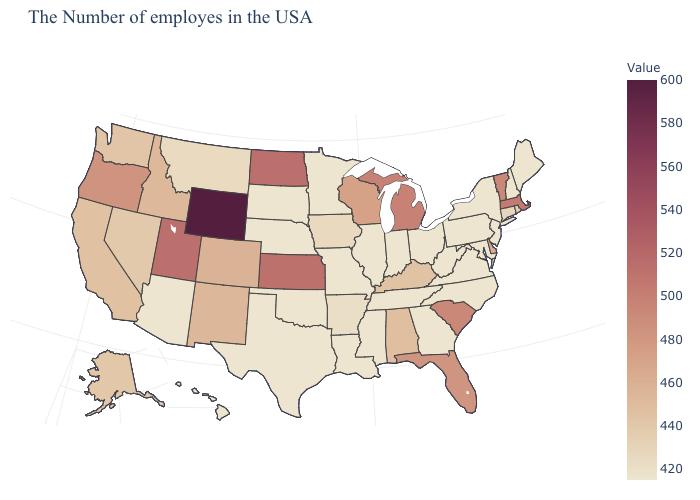Which states have the highest value in the USA?
Short answer required. Wyoming. Does Massachusetts have the lowest value in the USA?
Write a very short answer. No. Among the states that border North Carolina , does South Carolina have the highest value?
Short answer required. Yes. Is the legend a continuous bar?
Give a very brief answer. Yes. Which states hav the highest value in the MidWest?
Be succinct. North Dakota. Does the map have missing data?
Concise answer only. No. Does California have a lower value than Oklahoma?
Answer briefly. No. 